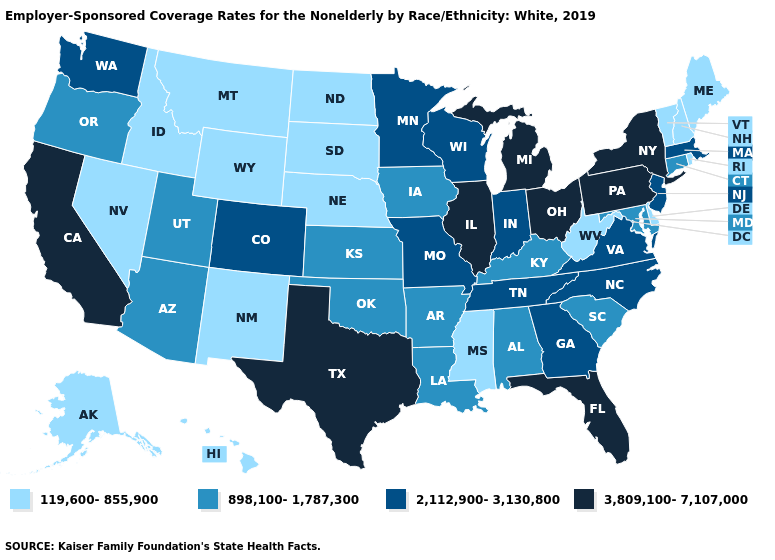Name the states that have a value in the range 3,809,100-7,107,000?
Concise answer only. California, Florida, Illinois, Michigan, New York, Ohio, Pennsylvania, Texas. What is the value of Texas?
Write a very short answer. 3,809,100-7,107,000. What is the value of Texas?
Be succinct. 3,809,100-7,107,000. Does Kansas have the highest value in the MidWest?
Quick response, please. No. Name the states that have a value in the range 2,112,900-3,130,800?
Write a very short answer. Colorado, Georgia, Indiana, Massachusetts, Minnesota, Missouri, New Jersey, North Carolina, Tennessee, Virginia, Washington, Wisconsin. What is the lowest value in states that border Wyoming?
Short answer required. 119,600-855,900. Name the states that have a value in the range 2,112,900-3,130,800?
Be succinct. Colorado, Georgia, Indiana, Massachusetts, Minnesota, Missouri, New Jersey, North Carolina, Tennessee, Virginia, Washington, Wisconsin. Which states have the lowest value in the USA?
Concise answer only. Alaska, Delaware, Hawaii, Idaho, Maine, Mississippi, Montana, Nebraska, Nevada, New Hampshire, New Mexico, North Dakota, Rhode Island, South Dakota, Vermont, West Virginia, Wyoming. How many symbols are there in the legend?
Short answer required. 4. What is the lowest value in the USA?
Short answer required. 119,600-855,900. Name the states that have a value in the range 3,809,100-7,107,000?
Give a very brief answer. California, Florida, Illinois, Michigan, New York, Ohio, Pennsylvania, Texas. Which states have the lowest value in the USA?
Write a very short answer. Alaska, Delaware, Hawaii, Idaho, Maine, Mississippi, Montana, Nebraska, Nevada, New Hampshire, New Mexico, North Dakota, Rhode Island, South Dakota, Vermont, West Virginia, Wyoming. What is the lowest value in states that border Michigan?
Keep it brief. 2,112,900-3,130,800. Among the states that border Arizona , which have the lowest value?
Give a very brief answer. Nevada, New Mexico. Does California have the highest value in the USA?
Concise answer only. Yes. 